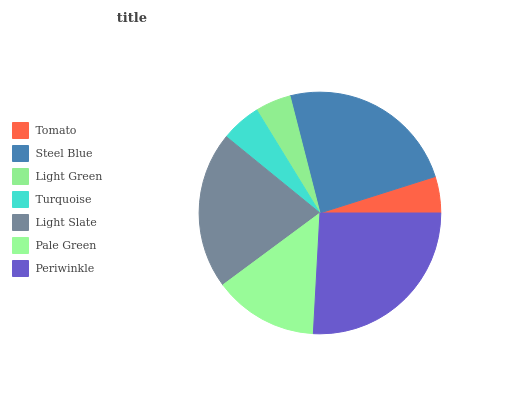Is Light Green the minimum?
Answer yes or no. Yes. Is Periwinkle the maximum?
Answer yes or no. Yes. Is Steel Blue the minimum?
Answer yes or no. No. Is Steel Blue the maximum?
Answer yes or no. No. Is Steel Blue greater than Tomato?
Answer yes or no. Yes. Is Tomato less than Steel Blue?
Answer yes or no. Yes. Is Tomato greater than Steel Blue?
Answer yes or no. No. Is Steel Blue less than Tomato?
Answer yes or no. No. Is Pale Green the high median?
Answer yes or no. Yes. Is Pale Green the low median?
Answer yes or no. Yes. Is Steel Blue the high median?
Answer yes or no. No. Is Periwinkle the low median?
Answer yes or no. No. 